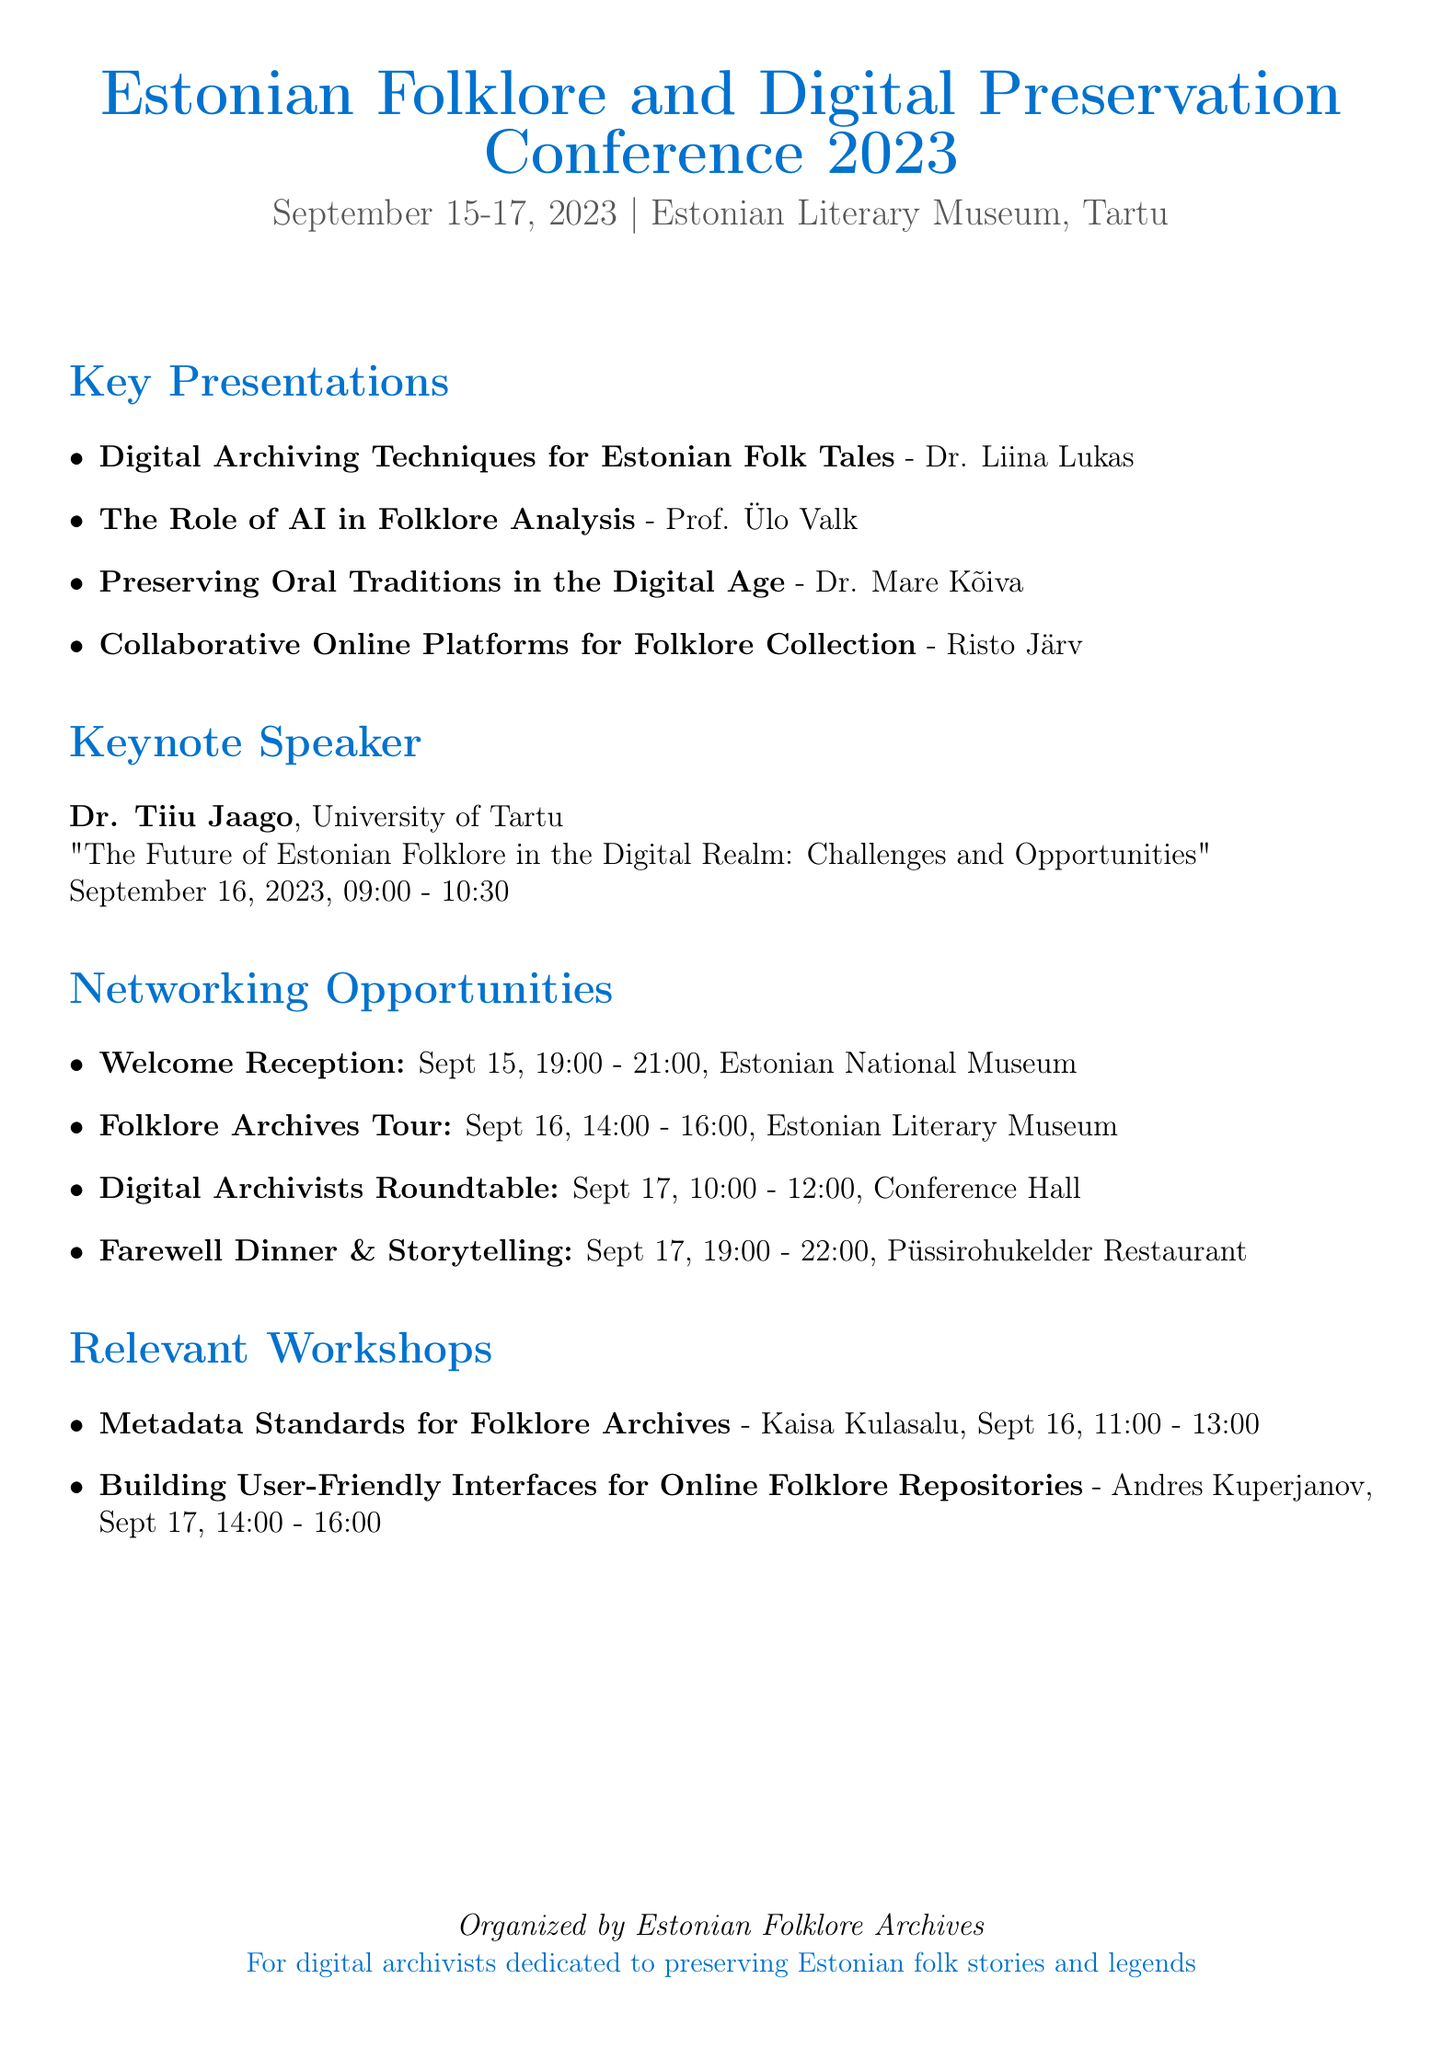What is the name of the conference? The name of the conference is explicitly mentioned in the document as "Estonian Folklore and Digital Preservation Conference 2023."
Answer: Estonian Folklore and Digital Preservation Conference 2023 When is the keynote speech scheduled? The date and time for the keynote speech are provided, indicating when it will take place during the conference.
Answer: September 16, 2023, 09:00 - 10:30 Who is the facilitator of the workshop on metadata standards? The document specifies the person responsible for leading the workshop on metadata standards, providing their name.
Answer: Kaisa Kulasalu How many networking opportunities are listed in the document? By counting the networking events provided, one can determine the total number available during the conference.
Answer: Four What is the location of the Welcome Reception? The location for the Welcome Reception event is stated in the document, specifying where it will occur.
Answer: Estonian National Museum, Tartu Which presenter is associated with digital archiving techniques? The document associates a specific presenter with the topic of digital archiving techniques, leading to a direct answer.
Answer: Dr. Liina Lukas What topic will Dr. Tiiu Jaago discuss? The document mentions the specific topic that will be discussed by the keynote speaker, forming a clear question and answer.
Answer: The Future of Estonian Folklore in the Digital Realm: Challenges and Opportunities What is the date of the Digital Archivists Roundtable? The document provides the specific date for the Digital Archivists Roundtable, making it easy to identify.
Answer: September 17, 2023 